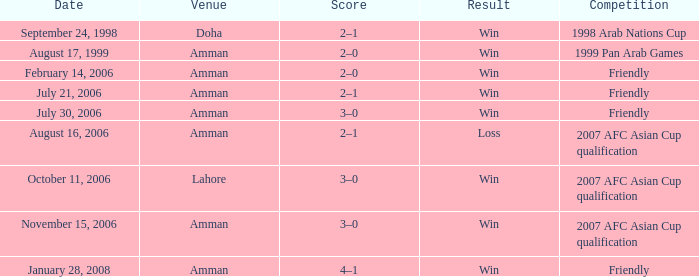Which competition took place on October 11, 2006? 2007 AFC Asian Cup qualification. 